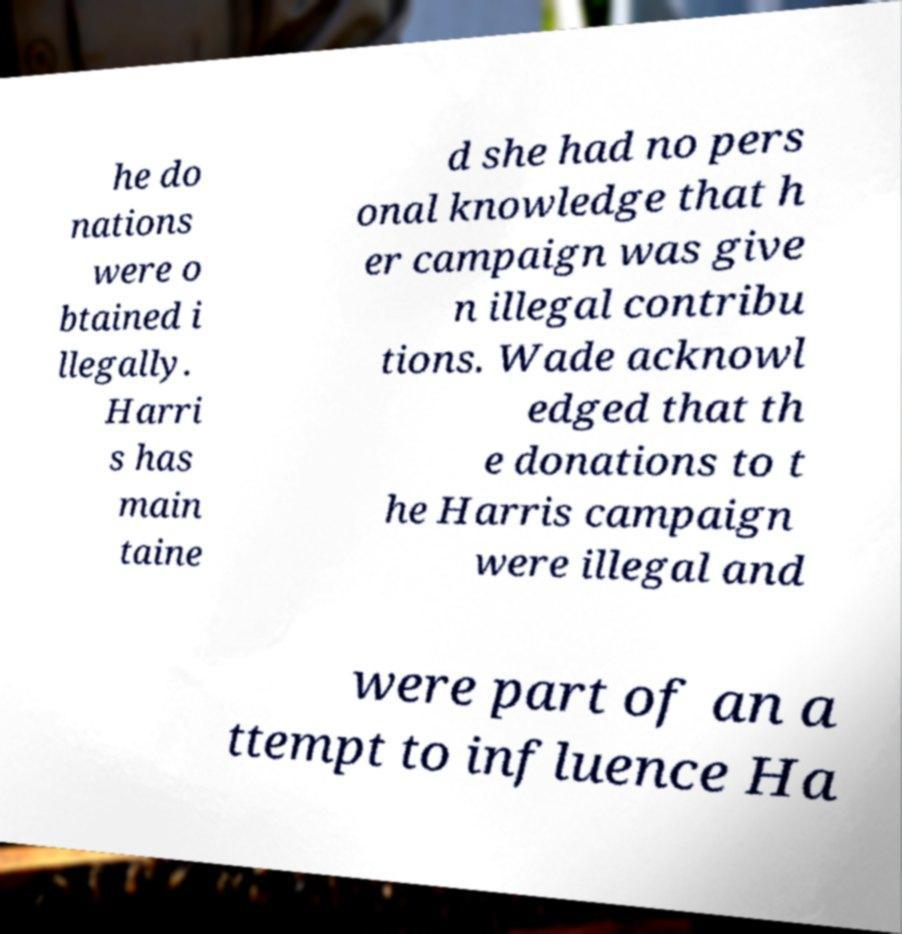What messages or text are displayed in this image? I need them in a readable, typed format. he do nations were o btained i llegally. Harri s has main taine d she had no pers onal knowledge that h er campaign was give n illegal contribu tions. Wade acknowl edged that th e donations to t he Harris campaign were illegal and were part of an a ttempt to influence Ha 